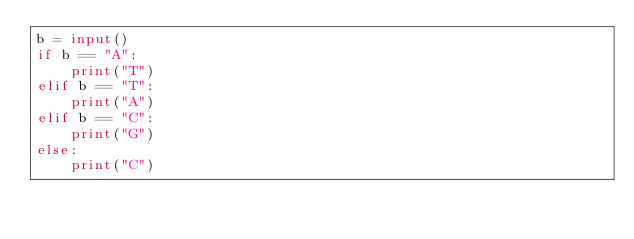<code> <loc_0><loc_0><loc_500><loc_500><_Python_>b = input()
if b == "A":
    print("T")
elif b == "T":
    print("A")
elif b == "C":
    print("G")
else:
    print("C")
    </code> 